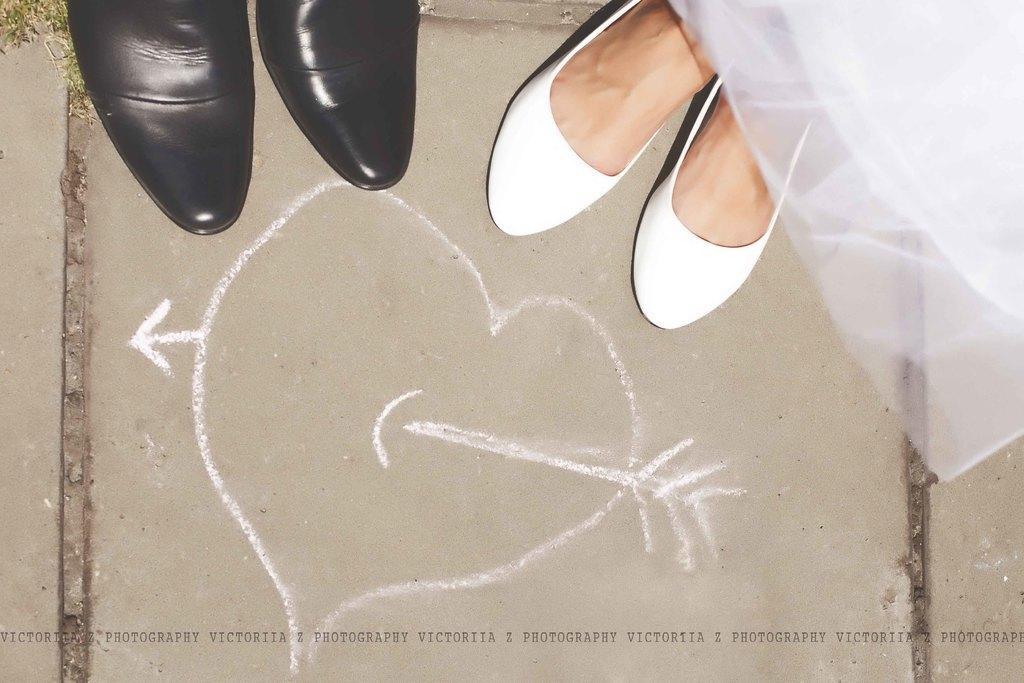How would you summarize this image in a sentence or two? In this image we can see human legs and frock and grass on the floor. 